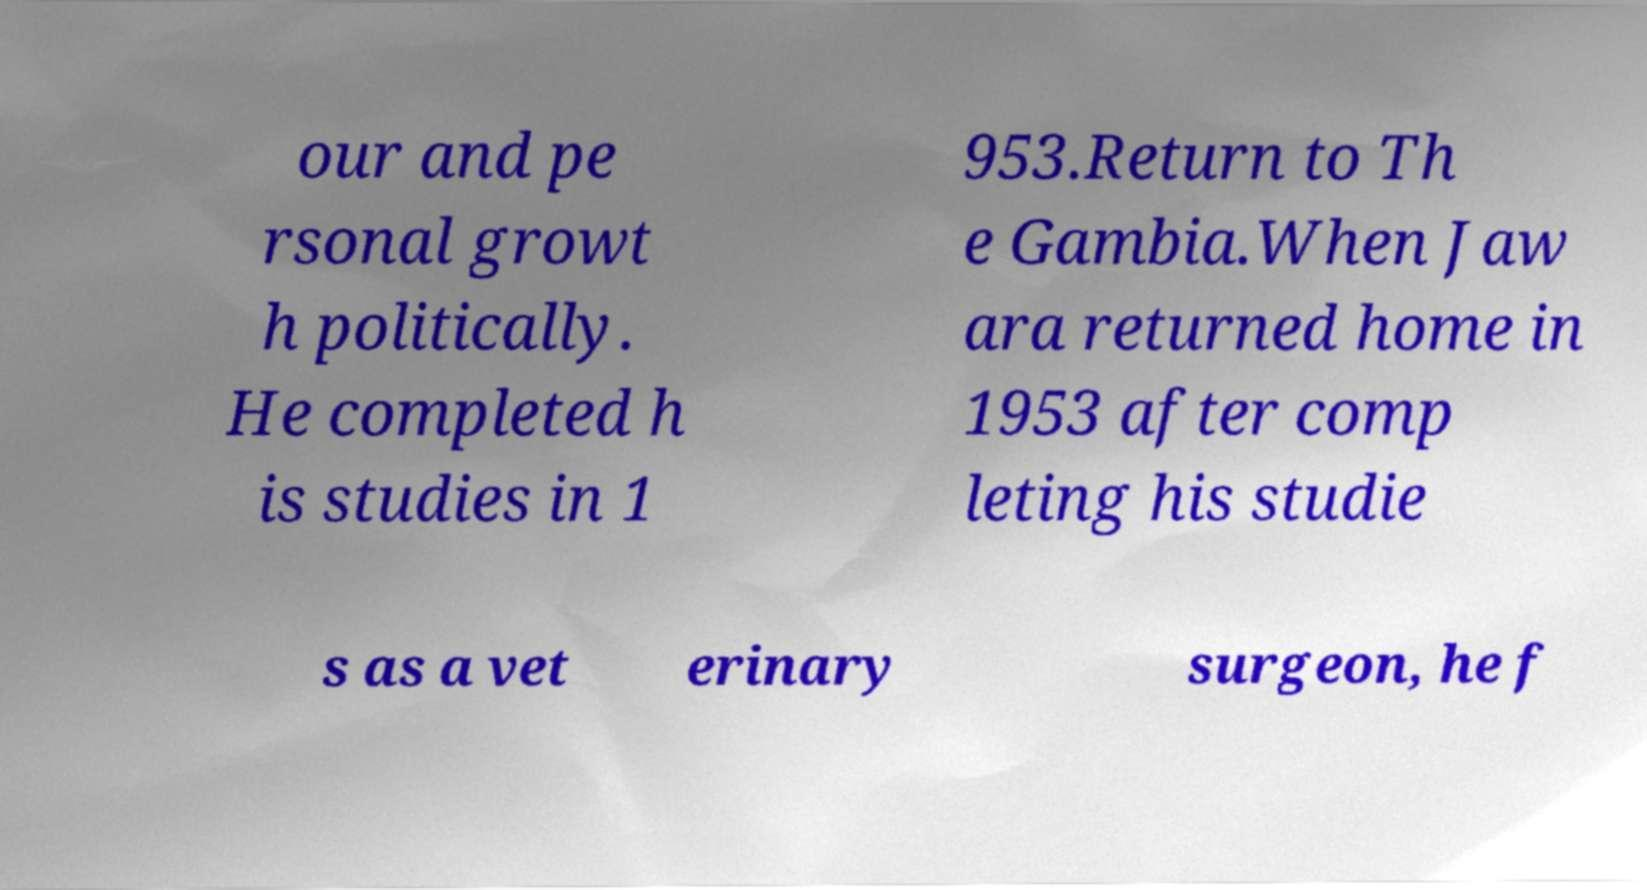Could you extract and type out the text from this image? our and pe rsonal growt h politically. He completed h is studies in 1 953.Return to Th e Gambia.When Jaw ara returned home in 1953 after comp leting his studie s as a vet erinary surgeon, he f 